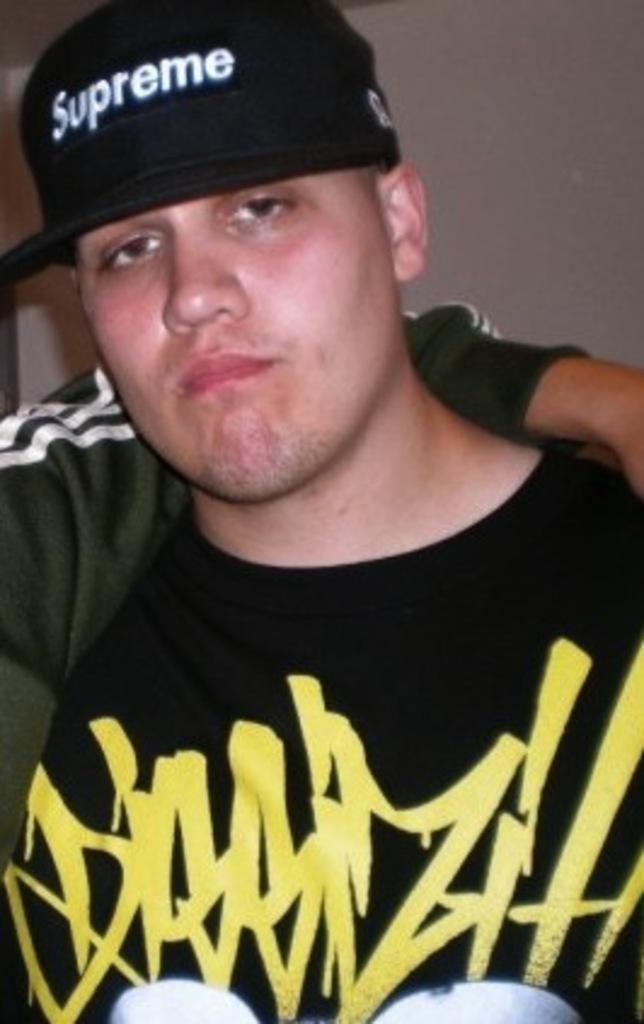What does this toolbag's hat say?
Your response must be concise. Supreme. 